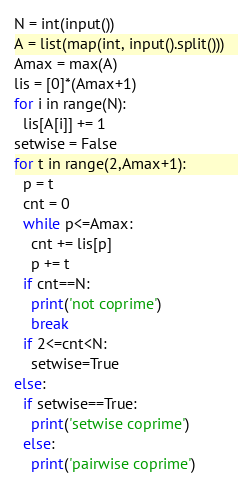<code> <loc_0><loc_0><loc_500><loc_500><_Cython_>N = int(input())
A = list(map(int, input().split()))
Amax = max(A)
lis = [0]*(Amax+1)
for i in range(N):
  lis[A[i]] += 1
setwise = False
for t in range(2,Amax+1):
  p = t
  cnt = 0
  while p<=Amax:
    cnt += lis[p]
    p += t
  if cnt==N:
    print('not coprime')
    break
  if 2<=cnt<N:
    setwise=True
else:
  if setwise==True:
    print('setwise coprime')
  else:
    print('pairwise coprime')
</code> 